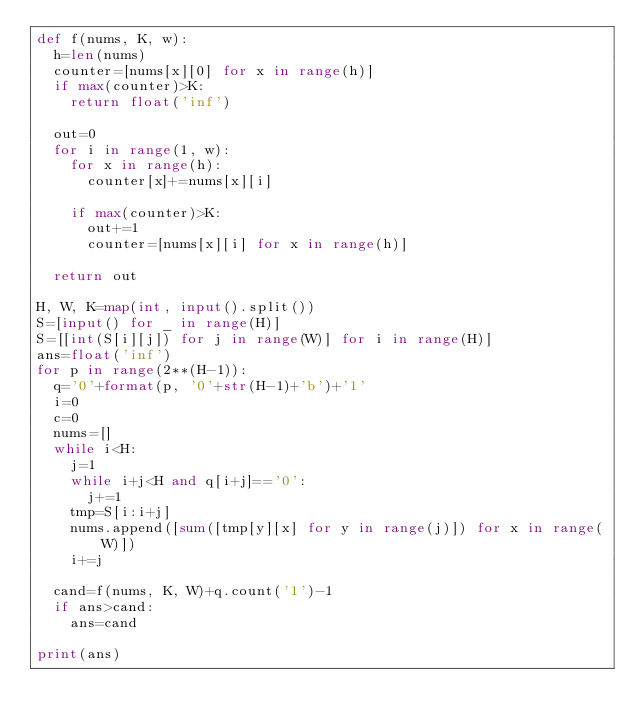<code> <loc_0><loc_0><loc_500><loc_500><_Python_>def f(nums, K, w):
  h=len(nums)
  counter=[nums[x][0] for x in range(h)]
  if max(counter)>K:
    return float('inf')
  
  out=0
  for i in range(1, w):
    for x in range(h):
      counter[x]+=nums[x][i]
      
    if max(counter)>K:
      out+=1
      counter=[nums[x][i] for x in range(h)]
      
  return out

H, W, K=map(int, input().split())
S=[input() for _ in range(H)]
S=[[int(S[i][j]) for j in range(W)] for i in range(H)]
ans=float('inf')
for p in range(2**(H-1)):
  q='0'+format(p, '0'+str(H-1)+'b')+'1'
  i=0
  c=0
  nums=[]
  while i<H:
    j=1
    while i+j<H and q[i+j]=='0':
      j+=1
    tmp=S[i:i+j]
    nums.append([sum([tmp[y][x] for y in range(j)]) for x in range(W)])
    i+=j
    
  cand=f(nums, K, W)+q.count('1')-1
  if ans>cand:
    ans=cand
    
print(ans)</code> 